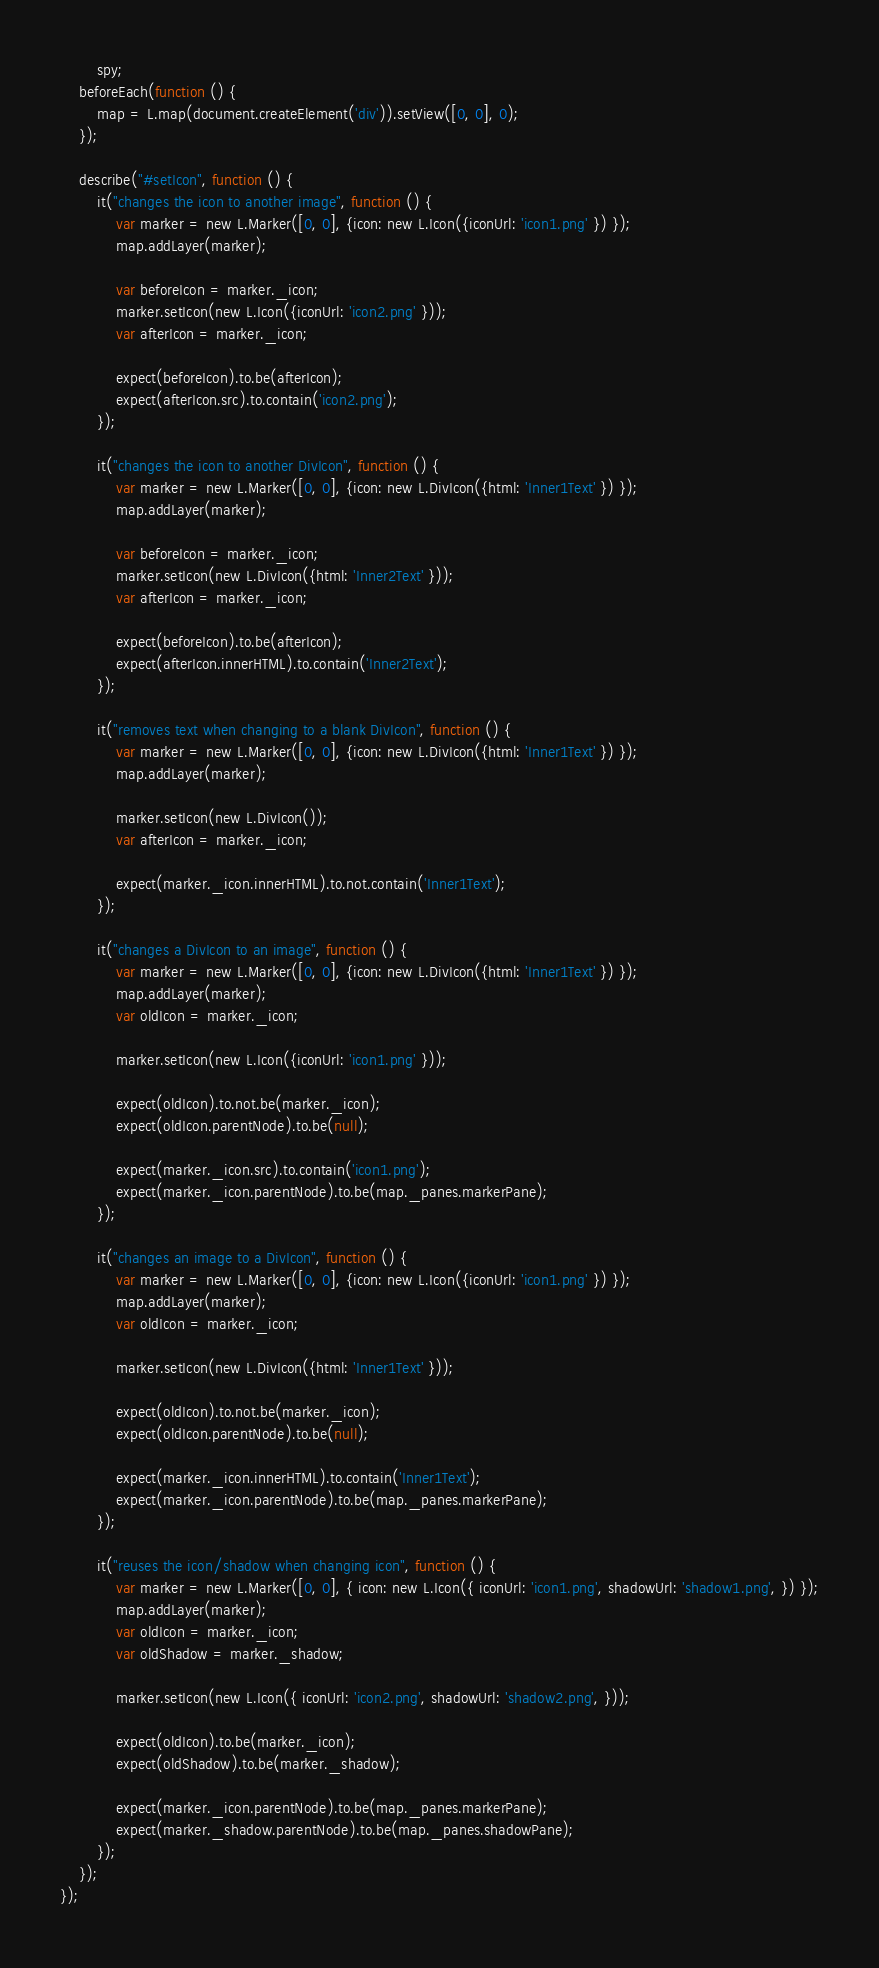Convert code to text. <code><loc_0><loc_0><loc_500><loc_500><_JavaScript_>		spy;
	beforeEach(function () {
		map = L.map(document.createElement('div')).setView([0, 0], 0);
	});

	describe("#setIcon", function () {
		it("changes the icon to another image", function () {
			var marker = new L.Marker([0, 0], {icon: new L.Icon({iconUrl: 'icon1.png' }) });
			map.addLayer(marker);
			
			var beforeIcon = marker._icon;
			marker.setIcon(new L.Icon({iconUrl: 'icon2.png' }));
			var afterIcon = marker._icon;
			
			expect(beforeIcon).to.be(afterIcon);
			expect(afterIcon.src).to.contain('icon2.png');
		});

		it("changes the icon to another DivIcon", function () {
			var marker = new L.Marker([0, 0], {icon: new L.DivIcon({html: 'Inner1Text' }) });
			map.addLayer(marker);
			
			var beforeIcon = marker._icon;
			marker.setIcon(new L.DivIcon({html: 'Inner2Text' }));
			var afterIcon = marker._icon;
			
			expect(beforeIcon).to.be(afterIcon);
			expect(afterIcon.innerHTML).to.contain('Inner2Text');
		});

		it("removes text when changing to a blank DivIcon", function () {
			var marker = new L.Marker([0, 0], {icon: new L.DivIcon({html: 'Inner1Text' }) });
			map.addLayer(marker);
			
			marker.setIcon(new L.DivIcon());
			var afterIcon = marker._icon;
			
			expect(marker._icon.innerHTML).to.not.contain('Inner1Text');
		});

		it("changes a DivIcon to an image", function () {
			var marker = new L.Marker([0, 0], {icon: new L.DivIcon({html: 'Inner1Text' }) });
			map.addLayer(marker);
			var oldIcon = marker._icon;
			
			marker.setIcon(new L.Icon({iconUrl: 'icon1.png' }));
			
			expect(oldIcon).to.not.be(marker._icon);
			expect(oldIcon.parentNode).to.be(null);
			
			expect(marker._icon.src).to.contain('icon1.png');
			expect(marker._icon.parentNode).to.be(map._panes.markerPane);
		});

		it("changes an image to a DivIcon", function () {
			var marker = new L.Marker([0, 0], {icon: new L.Icon({iconUrl: 'icon1.png' }) });
			map.addLayer(marker);
			var oldIcon = marker._icon;

			marker.setIcon(new L.DivIcon({html: 'Inner1Text' }));
			
			expect(oldIcon).to.not.be(marker._icon);
			expect(oldIcon.parentNode).to.be(null);
			
			expect(marker._icon.innerHTML).to.contain('Inner1Text');
			expect(marker._icon.parentNode).to.be(map._panes.markerPane);
		});

		it("reuses the icon/shadow when changing icon", function () {
			var marker = new L.Marker([0, 0], { icon: new L.Icon({ iconUrl: 'icon1.png', shadowUrl: 'shadow1.png', }) });
			map.addLayer(marker);
			var oldIcon = marker._icon;
			var oldShadow = marker._shadow;

			marker.setIcon(new L.Icon({ iconUrl: 'icon2.png', shadowUrl: 'shadow2.png', }));

			expect(oldIcon).to.be(marker._icon);
			expect(oldShadow).to.be(marker._shadow);

			expect(marker._icon.parentNode).to.be(map._panes.markerPane);
			expect(marker._shadow.parentNode).to.be(map._panes.shadowPane);
		});
	});
});</code> 